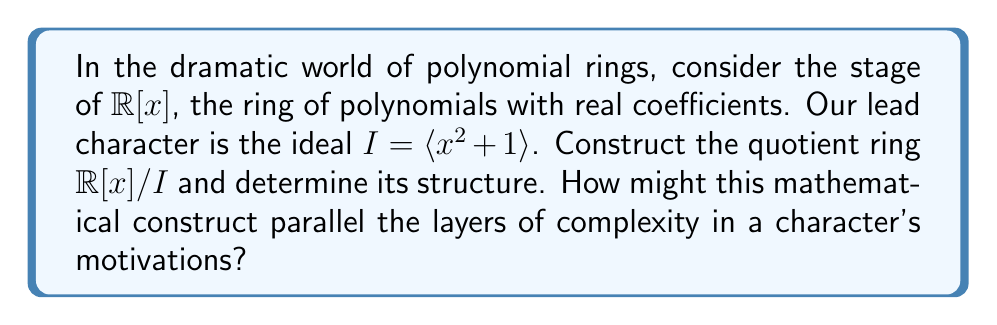Give your solution to this math problem. 1) First, we need to understand what the quotient ring $\mathbb{R}[x]/I$ represents. It consists of all cosets of the form $f(x) + I$, where $f(x) \in \mathbb{R}[x]$.

2) The key observation is that in this quotient ring, $x^2 + 1 \equiv 0$, or equivalently, $x^2 \equiv -1$.

3) This means that any polynomial in $\mathbb{R}[x]/I$ can be reduced to a linear polynomial $ax + b$, where $a, b \in \mathbb{R}$. This is because any higher power of $x$ can be reduced using $x^2 \equiv -1$.

4) We can represent any element of $\mathbb{R}[x]/I$ uniquely in the form $ax + b$, where $a, b \in \mathbb{R}$.

5) This structure is isomorphic to the complex numbers $\mathbb{C}$. We can establish this isomorphism by mapping $ax + b$ to $a + bi$.

6) The operations in $\mathbb{R}[x]/I$ correspond exactly to operations in $\mathbb{C}$:
   
   Addition: $(ax + b) + (cx + d) = (a+c)x + (b+d)$
   Multiplication: $(ax + b)(cx + d) = (ac)x^2 + (ad+bc)x + bd \equiv (ad+bc)x + (bd-ac)$

7) These operations mirror complex number arithmetic, confirming the isomorphism.

8) Just as a character's motivations can be complex and multifaceted, represented by the interplay between their surface actions (real part) and deeper drives (imaginary part), so too does this quotient ring represent a more complex structure built from simpler components.
Answer: $\mathbb{R}[x]/\langle x^2 + 1 \rangle \cong \mathbb{C}$ 